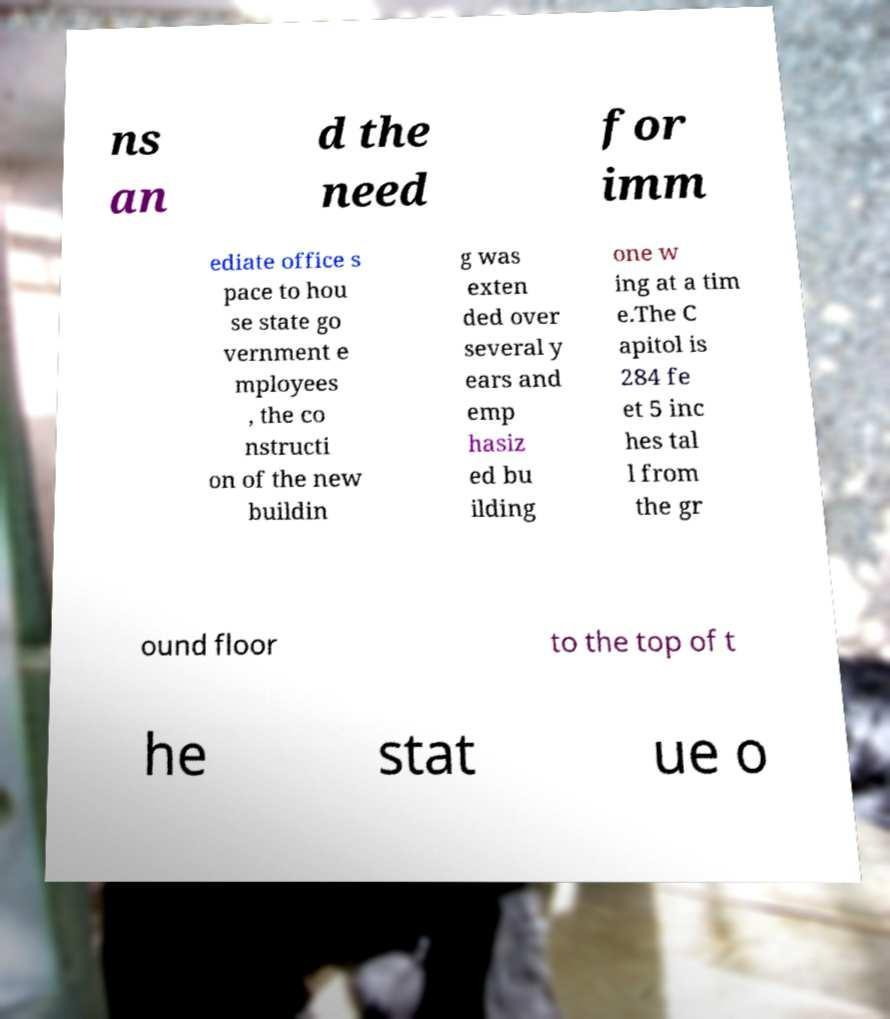Can you read and provide the text displayed in the image?This photo seems to have some interesting text. Can you extract and type it out for me? ns an d the need for imm ediate office s pace to hou se state go vernment e mployees , the co nstructi on of the new buildin g was exten ded over several y ears and emp hasiz ed bu ilding one w ing at a tim e.The C apitol is 284 fe et 5 inc hes tal l from the gr ound floor to the top of t he stat ue o 